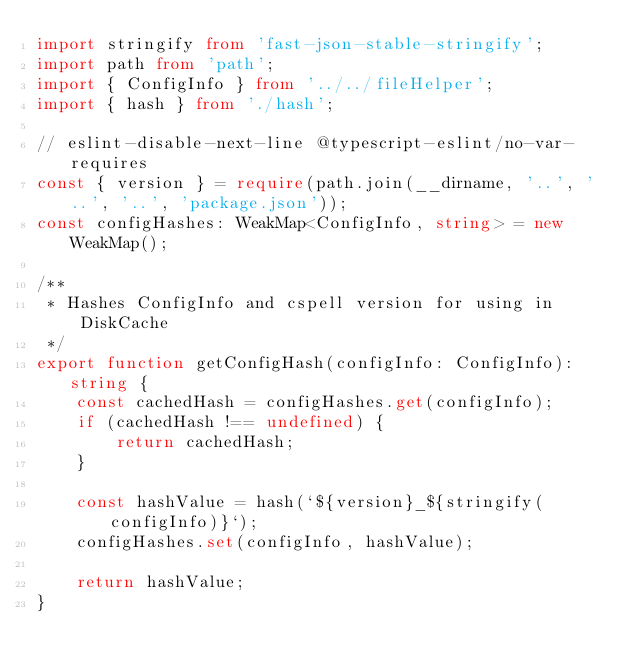Convert code to text. <code><loc_0><loc_0><loc_500><loc_500><_TypeScript_>import stringify from 'fast-json-stable-stringify';
import path from 'path';
import { ConfigInfo } from '../../fileHelper';
import { hash } from './hash';

// eslint-disable-next-line @typescript-eslint/no-var-requires
const { version } = require(path.join(__dirname, '..', '..', '..', 'package.json'));
const configHashes: WeakMap<ConfigInfo, string> = new WeakMap();

/**
 * Hashes ConfigInfo and cspell version for using in DiskCache
 */
export function getConfigHash(configInfo: ConfigInfo): string {
    const cachedHash = configHashes.get(configInfo);
    if (cachedHash !== undefined) {
        return cachedHash;
    }

    const hashValue = hash(`${version}_${stringify(configInfo)}`);
    configHashes.set(configInfo, hashValue);

    return hashValue;
}
</code> 